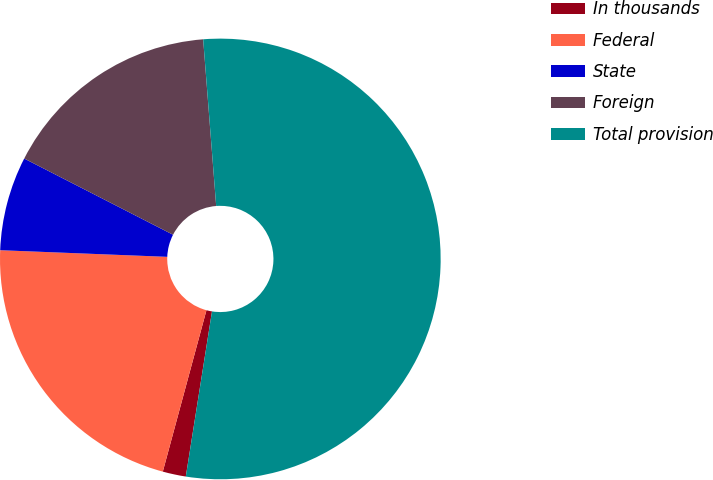<chart> <loc_0><loc_0><loc_500><loc_500><pie_chart><fcel>In thousands<fcel>Federal<fcel>State<fcel>Foreign<fcel>Total provision<nl><fcel>1.7%<fcel>21.43%<fcel>6.9%<fcel>16.23%<fcel>53.75%<nl></chart> 